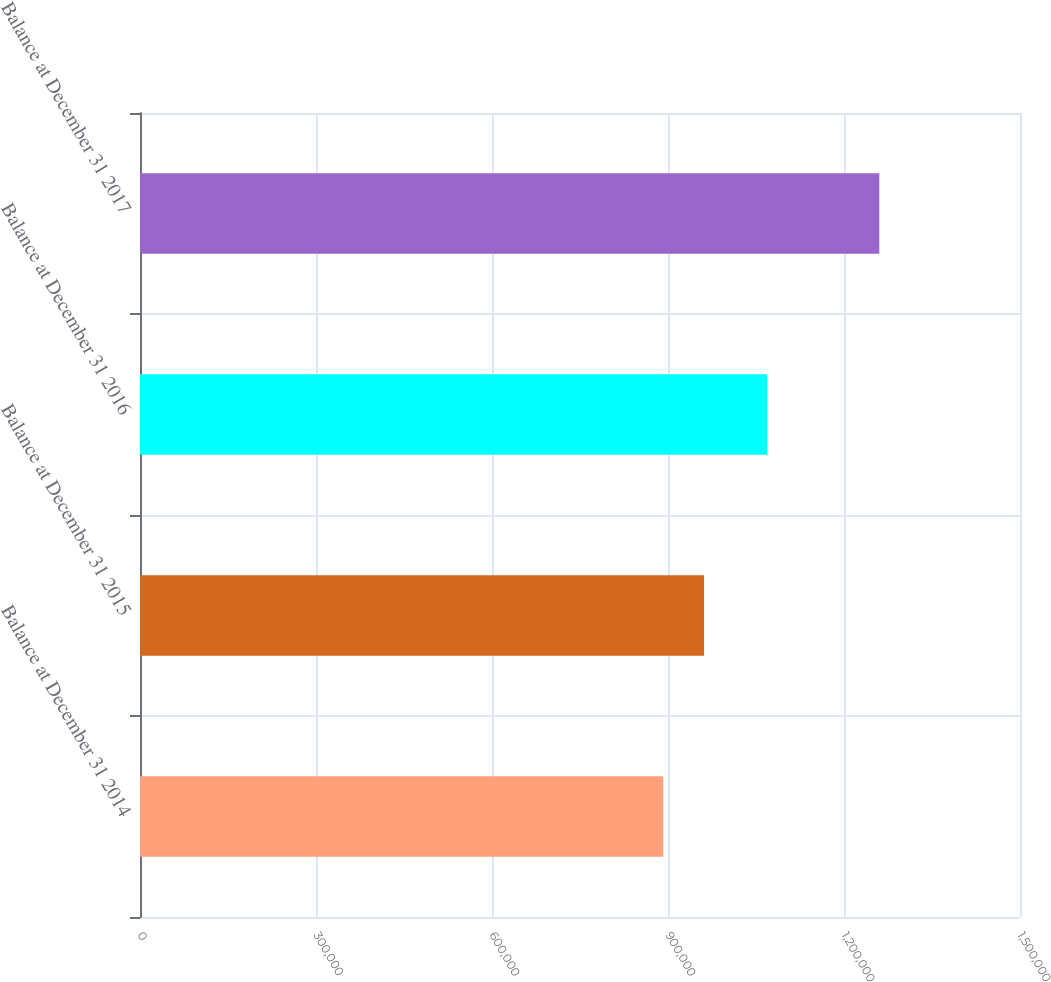Convert chart. <chart><loc_0><loc_0><loc_500><loc_500><bar_chart><fcel>Balance at December 31 2014<fcel>Balance at December 31 2015<fcel>Balance at December 31 2016<fcel>Balance at December 31 2017<nl><fcel>891831<fcel>961456<fcel>1.06899e+06<fcel>1.26017e+06<nl></chart> 